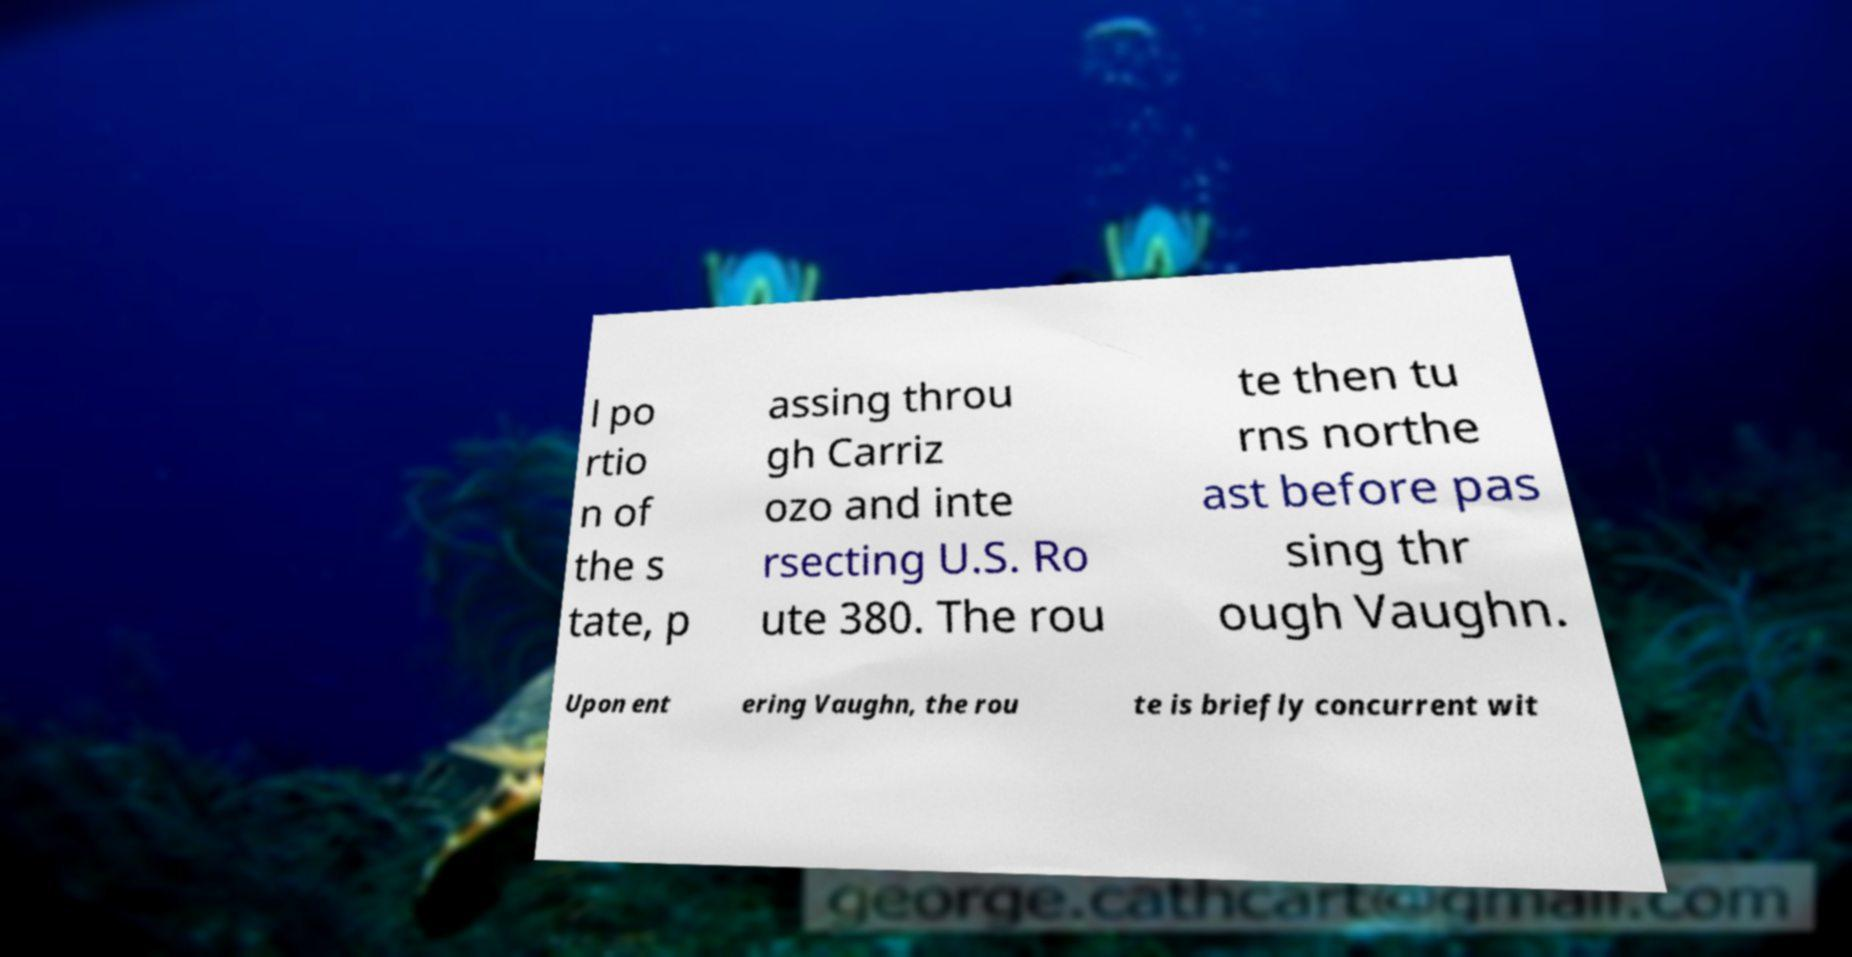Can you read and provide the text displayed in the image?This photo seems to have some interesting text. Can you extract and type it out for me? l po rtio n of the s tate, p assing throu gh Carriz ozo and inte rsecting U.S. Ro ute 380. The rou te then tu rns northe ast before pas sing thr ough Vaughn. Upon ent ering Vaughn, the rou te is briefly concurrent wit 